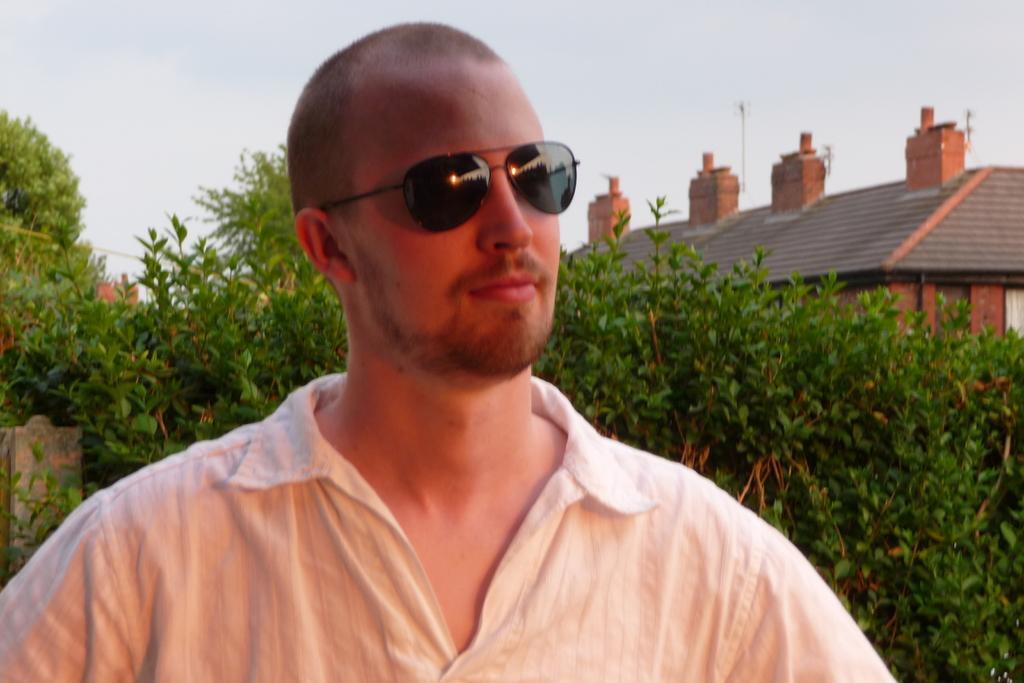How would you summarize this image in a sentence or two? In this picture I can see trees and buildings on the back and I can see a man standing and he wore sunglasses on his face and I can see a cloudy sky. 